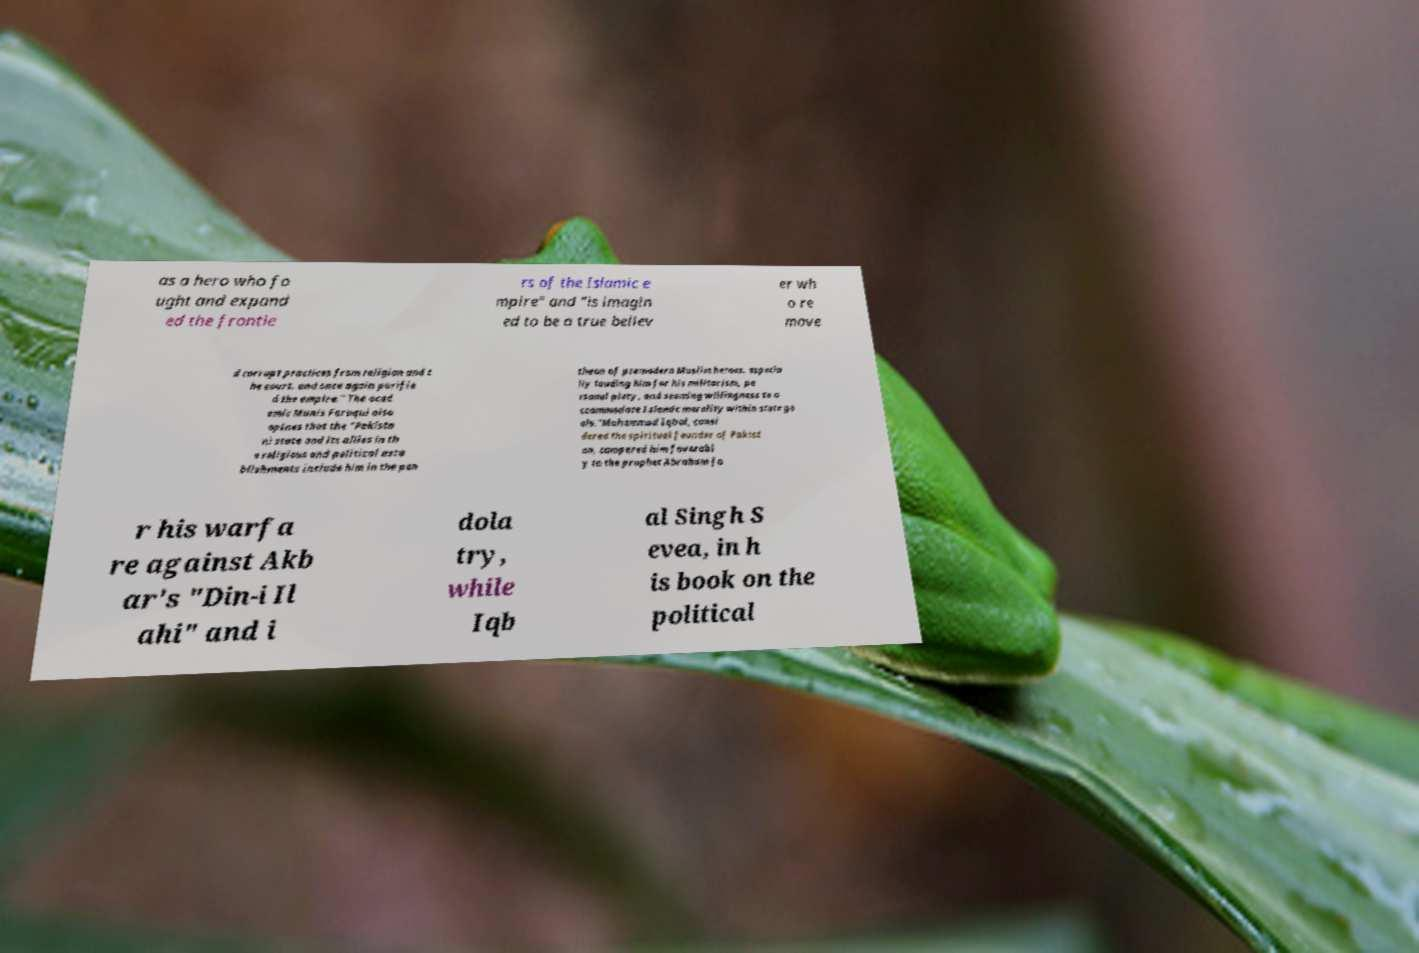There's text embedded in this image that I need extracted. Can you transcribe it verbatim? as a hero who fo ught and expand ed the frontie rs of the Islamic e mpire" and "is imagin ed to be a true believ er wh o re move d corrupt practices from religion and t he court, and once again purifie d the empire." The acad emic Munis Faruqui also opines that the "Pakista ni state and its allies in th e religious and political esta blishments include him in the pan theon of premodern Muslim heroes, especia lly lauding him for his militarism, pe rsonal piety, and seeming willingness to a ccommodate Islamic morality within state go als."Muhammad Iqbal, consi dered the spiritual founder of Pakist an, compared him favorabl y to the prophet Abraham fo r his warfa re against Akb ar's "Din-i Il ahi" and i dola try, while Iqb al Singh S evea, in h is book on the political 